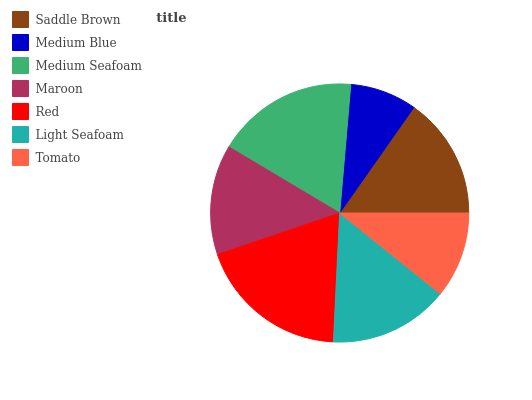Is Medium Blue the minimum?
Answer yes or no. Yes. Is Red the maximum?
Answer yes or no. Yes. Is Medium Seafoam the minimum?
Answer yes or no. No. Is Medium Seafoam the maximum?
Answer yes or no. No. Is Medium Seafoam greater than Medium Blue?
Answer yes or no. Yes. Is Medium Blue less than Medium Seafoam?
Answer yes or no. Yes. Is Medium Blue greater than Medium Seafoam?
Answer yes or no. No. Is Medium Seafoam less than Medium Blue?
Answer yes or no. No. Is Light Seafoam the high median?
Answer yes or no. Yes. Is Light Seafoam the low median?
Answer yes or no. Yes. Is Medium Seafoam the high median?
Answer yes or no. No. Is Medium Blue the low median?
Answer yes or no. No. 